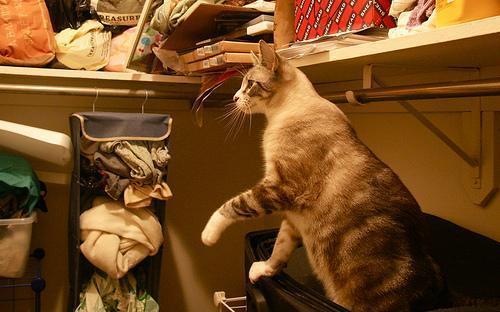How many women are there?
Give a very brief answer. 0. 